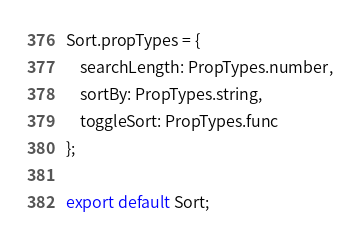Convert code to text. <code><loc_0><loc_0><loc_500><loc_500><_JavaScript_>Sort.propTypes = {
	searchLength: PropTypes.number,
	sortBy: PropTypes.string,
	toggleSort: PropTypes.func
};

export default Sort;
</code> 